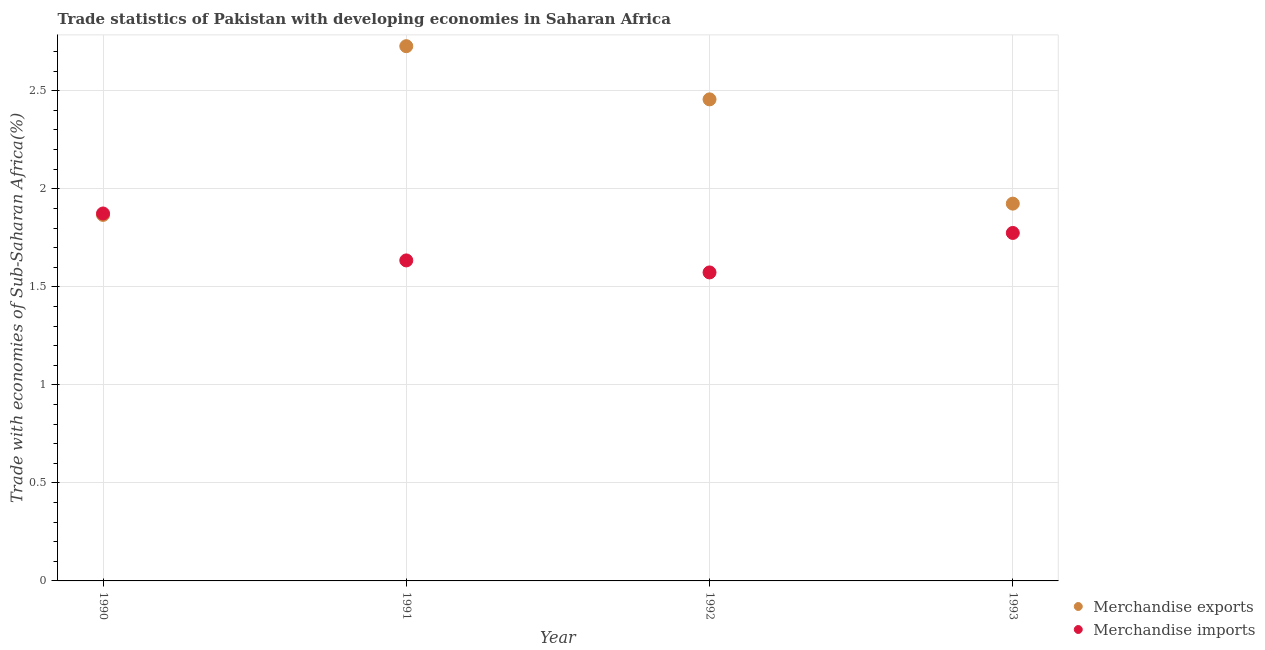How many different coloured dotlines are there?
Keep it short and to the point. 2. What is the merchandise exports in 1992?
Offer a terse response. 2.46. Across all years, what is the maximum merchandise imports?
Your answer should be very brief. 1.87. Across all years, what is the minimum merchandise imports?
Give a very brief answer. 1.57. In which year was the merchandise exports minimum?
Your answer should be very brief. 1990. What is the total merchandise imports in the graph?
Your response must be concise. 6.86. What is the difference between the merchandise imports in 1991 and that in 1992?
Your answer should be compact. 0.06. What is the difference between the merchandise imports in 1990 and the merchandise exports in 1992?
Ensure brevity in your answer.  -0.58. What is the average merchandise exports per year?
Keep it short and to the point. 2.24. In the year 1991, what is the difference between the merchandise exports and merchandise imports?
Make the answer very short. 1.09. What is the ratio of the merchandise exports in 1991 to that in 1992?
Offer a very short reply. 1.11. What is the difference between the highest and the second highest merchandise imports?
Provide a succinct answer. 0.1. What is the difference between the highest and the lowest merchandise exports?
Give a very brief answer. 0.86. In how many years, is the merchandise imports greater than the average merchandise imports taken over all years?
Your response must be concise. 2. Does the merchandise imports monotonically increase over the years?
Provide a short and direct response. No. How many dotlines are there?
Provide a short and direct response. 2. How many years are there in the graph?
Keep it short and to the point. 4. What is the difference between two consecutive major ticks on the Y-axis?
Provide a succinct answer. 0.5. Does the graph contain grids?
Your answer should be very brief. Yes. Where does the legend appear in the graph?
Ensure brevity in your answer.  Bottom right. How many legend labels are there?
Your response must be concise. 2. What is the title of the graph?
Ensure brevity in your answer.  Trade statistics of Pakistan with developing economies in Saharan Africa. Does "Export" appear as one of the legend labels in the graph?
Keep it short and to the point. No. What is the label or title of the Y-axis?
Offer a terse response. Trade with economies of Sub-Saharan Africa(%). What is the Trade with economies of Sub-Saharan Africa(%) of Merchandise exports in 1990?
Your answer should be very brief. 1.87. What is the Trade with economies of Sub-Saharan Africa(%) of Merchandise imports in 1990?
Provide a short and direct response. 1.87. What is the Trade with economies of Sub-Saharan Africa(%) in Merchandise exports in 1991?
Your response must be concise. 2.73. What is the Trade with economies of Sub-Saharan Africa(%) of Merchandise imports in 1991?
Make the answer very short. 1.63. What is the Trade with economies of Sub-Saharan Africa(%) of Merchandise exports in 1992?
Offer a very short reply. 2.46. What is the Trade with economies of Sub-Saharan Africa(%) of Merchandise imports in 1992?
Keep it short and to the point. 1.57. What is the Trade with economies of Sub-Saharan Africa(%) in Merchandise exports in 1993?
Your response must be concise. 1.92. What is the Trade with economies of Sub-Saharan Africa(%) in Merchandise imports in 1993?
Your answer should be very brief. 1.77. Across all years, what is the maximum Trade with economies of Sub-Saharan Africa(%) in Merchandise exports?
Provide a succinct answer. 2.73. Across all years, what is the maximum Trade with economies of Sub-Saharan Africa(%) of Merchandise imports?
Offer a very short reply. 1.87. Across all years, what is the minimum Trade with economies of Sub-Saharan Africa(%) of Merchandise exports?
Offer a very short reply. 1.87. Across all years, what is the minimum Trade with economies of Sub-Saharan Africa(%) in Merchandise imports?
Your answer should be very brief. 1.57. What is the total Trade with economies of Sub-Saharan Africa(%) of Merchandise exports in the graph?
Provide a short and direct response. 8.97. What is the total Trade with economies of Sub-Saharan Africa(%) in Merchandise imports in the graph?
Your response must be concise. 6.86. What is the difference between the Trade with economies of Sub-Saharan Africa(%) of Merchandise exports in 1990 and that in 1991?
Provide a short and direct response. -0.86. What is the difference between the Trade with economies of Sub-Saharan Africa(%) in Merchandise imports in 1990 and that in 1991?
Ensure brevity in your answer.  0.24. What is the difference between the Trade with economies of Sub-Saharan Africa(%) of Merchandise exports in 1990 and that in 1992?
Ensure brevity in your answer.  -0.59. What is the difference between the Trade with economies of Sub-Saharan Africa(%) of Merchandise imports in 1990 and that in 1992?
Ensure brevity in your answer.  0.3. What is the difference between the Trade with economies of Sub-Saharan Africa(%) of Merchandise exports in 1990 and that in 1993?
Offer a terse response. -0.06. What is the difference between the Trade with economies of Sub-Saharan Africa(%) in Merchandise imports in 1990 and that in 1993?
Give a very brief answer. 0.1. What is the difference between the Trade with economies of Sub-Saharan Africa(%) of Merchandise exports in 1991 and that in 1992?
Ensure brevity in your answer.  0.27. What is the difference between the Trade with economies of Sub-Saharan Africa(%) of Merchandise imports in 1991 and that in 1992?
Offer a very short reply. 0.06. What is the difference between the Trade with economies of Sub-Saharan Africa(%) in Merchandise exports in 1991 and that in 1993?
Offer a terse response. 0.8. What is the difference between the Trade with economies of Sub-Saharan Africa(%) of Merchandise imports in 1991 and that in 1993?
Provide a short and direct response. -0.14. What is the difference between the Trade with economies of Sub-Saharan Africa(%) in Merchandise exports in 1992 and that in 1993?
Your response must be concise. 0.53. What is the difference between the Trade with economies of Sub-Saharan Africa(%) of Merchandise imports in 1992 and that in 1993?
Provide a succinct answer. -0.2. What is the difference between the Trade with economies of Sub-Saharan Africa(%) in Merchandise exports in 1990 and the Trade with economies of Sub-Saharan Africa(%) in Merchandise imports in 1991?
Your response must be concise. 0.23. What is the difference between the Trade with economies of Sub-Saharan Africa(%) in Merchandise exports in 1990 and the Trade with economies of Sub-Saharan Africa(%) in Merchandise imports in 1992?
Offer a terse response. 0.29. What is the difference between the Trade with economies of Sub-Saharan Africa(%) in Merchandise exports in 1990 and the Trade with economies of Sub-Saharan Africa(%) in Merchandise imports in 1993?
Ensure brevity in your answer.  0.09. What is the difference between the Trade with economies of Sub-Saharan Africa(%) in Merchandise exports in 1991 and the Trade with economies of Sub-Saharan Africa(%) in Merchandise imports in 1992?
Provide a succinct answer. 1.15. What is the difference between the Trade with economies of Sub-Saharan Africa(%) in Merchandise exports in 1991 and the Trade with economies of Sub-Saharan Africa(%) in Merchandise imports in 1993?
Your answer should be compact. 0.95. What is the difference between the Trade with economies of Sub-Saharan Africa(%) of Merchandise exports in 1992 and the Trade with economies of Sub-Saharan Africa(%) of Merchandise imports in 1993?
Provide a short and direct response. 0.68. What is the average Trade with economies of Sub-Saharan Africa(%) of Merchandise exports per year?
Ensure brevity in your answer.  2.24. What is the average Trade with economies of Sub-Saharan Africa(%) in Merchandise imports per year?
Provide a short and direct response. 1.71. In the year 1990, what is the difference between the Trade with economies of Sub-Saharan Africa(%) of Merchandise exports and Trade with economies of Sub-Saharan Africa(%) of Merchandise imports?
Offer a terse response. -0.01. In the year 1991, what is the difference between the Trade with economies of Sub-Saharan Africa(%) in Merchandise exports and Trade with economies of Sub-Saharan Africa(%) in Merchandise imports?
Offer a terse response. 1.09. In the year 1992, what is the difference between the Trade with economies of Sub-Saharan Africa(%) of Merchandise exports and Trade with economies of Sub-Saharan Africa(%) of Merchandise imports?
Provide a short and direct response. 0.88. In the year 1993, what is the difference between the Trade with economies of Sub-Saharan Africa(%) in Merchandise exports and Trade with economies of Sub-Saharan Africa(%) in Merchandise imports?
Provide a succinct answer. 0.15. What is the ratio of the Trade with economies of Sub-Saharan Africa(%) in Merchandise exports in 1990 to that in 1991?
Offer a terse response. 0.68. What is the ratio of the Trade with economies of Sub-Saharan Africa(%) of Merchandise imports in 1990 to that in 1991?
Your answer should be compact. 1.15. What is the ratio of the Trade with economies of Sub-Saharan Africa(%) of Merchandise exports in 1990 to that in 1992?
Provide a succinct answer. 0.76. What is the ratio of the Trade with economies of Sub-Saharan Africa(%) of Merchandise imports in 1990 to that in 1992?
Give a very brief answer. 1.19. What is the ratio of the Trade with economies of Sub-Saharan Africa(%) in Merchandise exports in 1990 to that in 1993?
Your answer should be very brief. 0.97. What is the ratio of the Trade with economies of Sub-Saharan Africa(%) of Merchandise imports in 1990 to that in 1993?
Ensure brevity in your answer.  1.06. What is the ratio of the Trade with economies of Sub-Saharan Africa(%) of Merchandise exports in 1991 to that in 1992?
Give a very brief answer. 1.11. What is the ratio of the Trade with economies of Sub-Saharan Africa(%) in Merchandise imports in 1991 to that in 1992?
Your answer should be very brief. 1.04. What is the ratio of the Trade with economies of Sub-Saharan Africa(%) of Merchandise exports in 1991 to that in 1993?
Provide a succinct answer. 1.42. What is the ratio of the Trade with economies of Sub-Saharan Africa(%) of Merchandise imports in 1991 to that in 1993?
Provide a short and direct response. 0.92. What is the ratio of the Trade with economies of Sub-Saharan Africa(%) of Merchandise exports in 1992 to that in 1993?
Your answer should be very brief. 1.28. What is the ratio of the Trade with economies of Sub-Saharan Africa(%) in Merchandise imports in 1992 to that in 1993?
Give a very brief answer. 0.89. What is the difference between the highest and the second highest Trade with economies of Sub-Saharan Africa(%) in Merchandise exports?
Offer a terse response. 0.27. What is the difference between the highest and the second highest Trade with economies of Sub-Saharan Africa(%) in Merchandise imports?
Provide a short and direct response. 0.1. What is the difference between the highest and the lowest Trade with economies of Sub-Saharan Africa(%) in Merchandise exports?
Ensure brevity in your answer.  0.86. What is the difference between the highest and the lowest Trade with economies of Sub-Saharan Africa(%) in Merchandise imports?
Offer a very short reply. 0.3. 